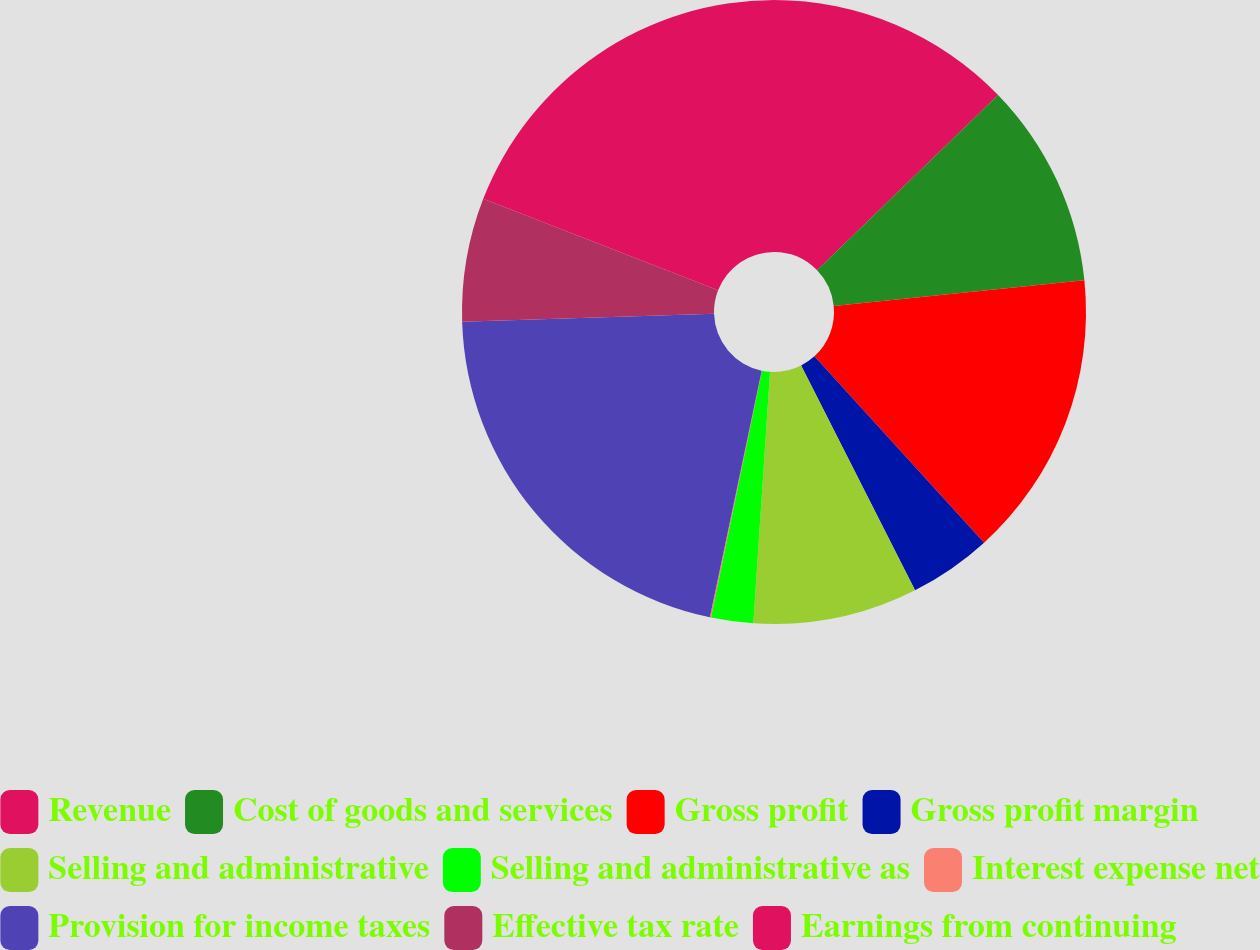<chart> <loc_0><loc_0><loc_500><loc_500><pie_chart><fcel>Revenue<fcel>Cost of goods and services<fcel>Gross profit<fcel>Gross profit margin<fcel>Selling and administrative<fcel>Selling and administrative as<fcel>Interest expense net<fcel>Provision for income taxes<fcel>Effective tax rate<fcel>Earnings from continuing<nl><fcel>12.75%<fcel>10.63%<fcel>14.86%<fcel>4.29%<fcel>8.52%<fcel>2.18%<fcel>0.06%<fcel>21.21%<fcel>6.4%<fcel>19.09%<nl></chart> 